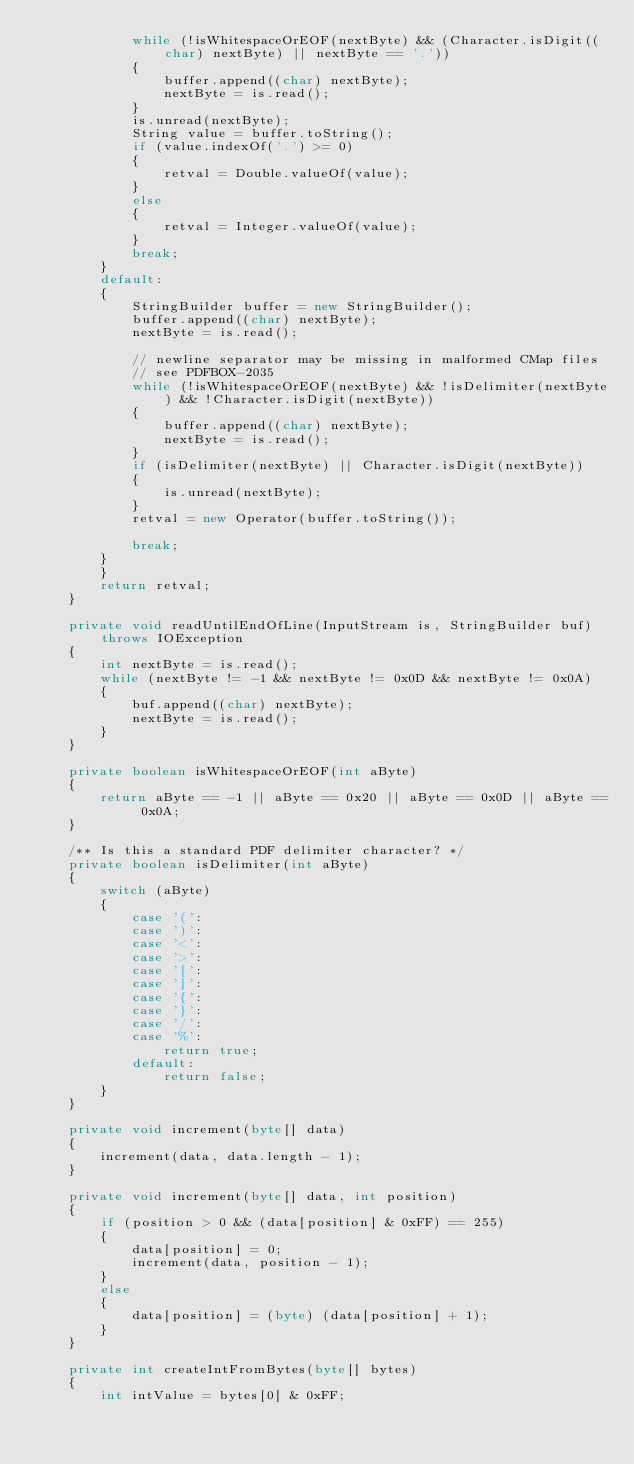Convert code to text. <code><loc_0><loc_0><loc_500><loc_500><_Java_>            while (!isWhitespaceOrEOF(nextByte) && (Character.isDigit((char) nextByte) || nextByte == '.'))
            {
                buffer.append((char) nextByte);
                nextByte = is.read();
            }
            is.unread(nextByte);
            String value = buffer.toString();
            if (value.indexOf('.') >= 0)
            {
                retval = Double.valueOf(value);
            }
            else
            {
                retval = Integer.valueOf(value);
            }
            break;
        }
        default:
        {
            StringBuilder buffer = new StringBuilder();
            buffer.append((char) nextByte);
            nextByte = is.read();

            // newline separator may be missing in malformed CMap files
            // see PDFBOX-2035
            while (!isWhitespaceOrEOF(nextByte) && !isDelimiter(nextByte) && !Character.isDigit(nextByte))
            {
                buffer.append((char) nextByte);
                nextByte = is.read();
            }
            if (isDelimiter(nextByte) || Character.isDigit(nextByte))
            {
                is.unread(nextByte);
            }
            retval = new Operator(buffer.toString());

            break;
        }
        }
        return retval;
    }

    private void readUntilEndOfLine(InputStream is, StringBuilder buf) throws IOException
    {
        int nextByte = is.read();
        while (nextByte != -1 && nextByte != 0x0D && nextByte != 0x0A)
        {
            buf.append((char) nextByte);
            nextByte = is.read();
        }
    }

    private boolean isWhitespaceOrEOF(int aByte)
    {
        return aByte == -1 || aByte == 0x20 || aByte == 0x0D || aByte == 0x0A;
    }

    /** Is this a standard PDF delimiter character? */
    private boolean isDelimiter(int aByte) 
    {
        switch (aByte) 
        {
            case '(':
            case ')':
            case '<':
            case '>':
            case '[':
            case ']':
            case '{':
            case '}':
            case '/':
            case '%':
                return true;
            default:
                return false;
        }
    }

    private void increment(byte[] data)
    {
        increment(data, data.length - 1);
    }

    private void increment(byte[] data, int position)
    {
        if (position > 0 && (data[position] & 0xFF) == 255)
        {
            data[position] = 0;
            increment(data, position - 1);
        }
        else
        {
            data[position] = (byte) (data[position] + 1);
        }
    }

    private int createIntFromBytes(byte[] bytes)
    {
        int intValue = bytes[0] & 0xFF;</code> 